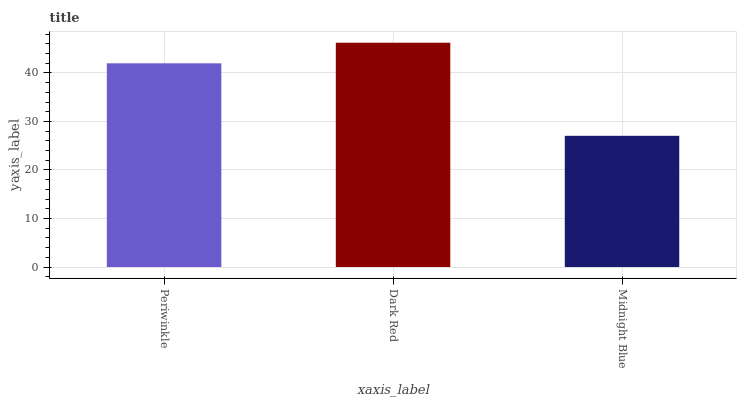Is Dark Red the minimum?
Answer yes or no. No. Is Midnight Blue the maximum?
Answer yes or no. No. Is Dark Red greater than Midnight Blue?
Answer yes or no. Yes. Is Midnight Blue less than Dark Red?
Answer yes or no. Yes. Is Midnight Blue greater than Dark Red?
Answer yes or no. No. Is Dark Red less than Midnight Blue?
Answer yes or no. No. Is Periwinkle the high median?
Answer yes or no. Yes. Is Periwinkle the low median?
Answer yes or no. Yes. Is Midnight Blue the high median?
Answer yes or no. No. Is Dark Red the low median?
Answer yes or no. No. 